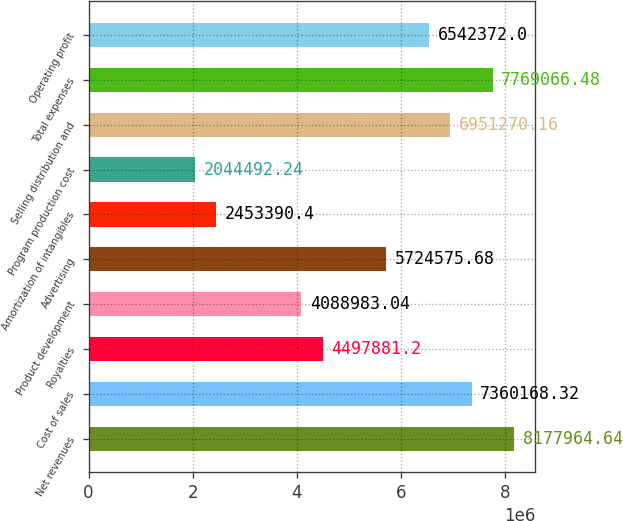<chart> <loc_0><loc_0><loc_500><loc_500><bar_chart><fcel>Net revenues<fcel>Cost of sales<fcel>Royalties<fcel>Product development<fcel>Advertising<fcel>Amortization of intangibles<fcel>Program production cost<fcel>Selling distribution and<fcel>Total expenses<fcel>Operating profit<nl><fcel>8.17796e+06<fcel>7.36017e+06<fcel>4.49788e+06<fcel>4.08898e+06<fcel>5.72458e+06<fcel>2.45339e+06<fcel>2.04449e+06<fcel>6.95127e+06<fcel>7.76907e+06<fcel>6.54237e+06<nl></chart> 